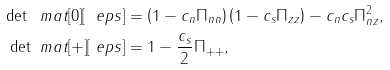<formula> <loc_0><loc_0><loc_500><loc_500>\det \ m a t [ 0 ] [ \ e p s ] & = \left ( 1 - c _ { n } \Pi _ { n n } \right ) \left ( 1 - c _ { s } \Pi _ { z z } \right ) - c _ { n } c _ { s } \Pi _ { n z } ^ { 2 } , \\ \det \ m a t [ + ] [ \ e p s ] & = 1 - \frac { c _ { s } } { 2 } \Pi _ { + + } ,</formula> 